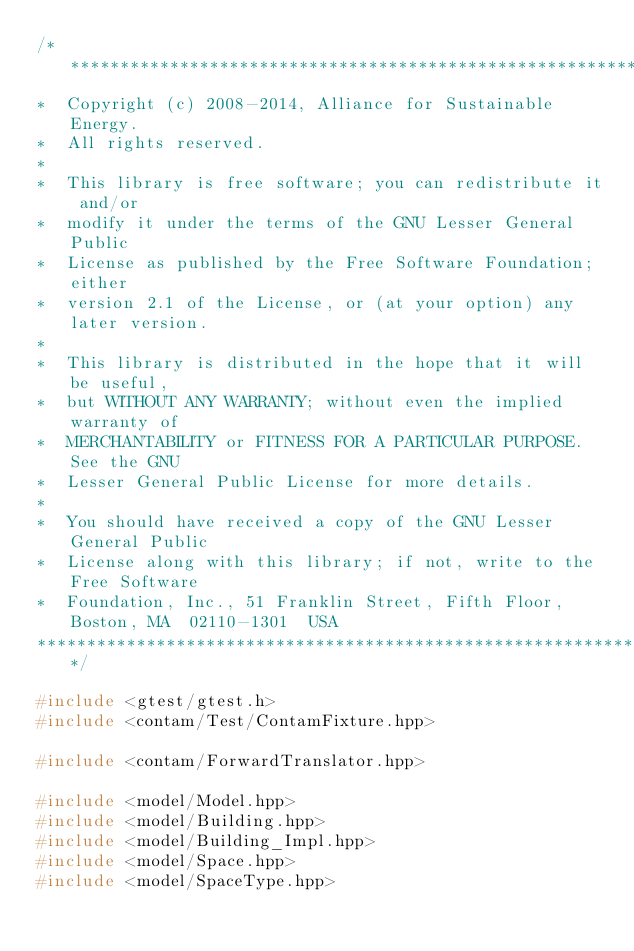<code> <loc_0><loc_0><loc_500><loc_500><_C++_>/**********************************************************************
*  Copyright (c) 2008-2014, Alliance for Sustainable Energy.
*  All rights reserved.
*
*  This library is free software; you can redistribute it and/or
*  modify it under the terms of the GNU Lesser General Public
*  License as published by the Free Software Foundation; either
*  version 2.1 of the License, or (at your option) any later version.
*
*  This library is distributed in the hope that it will be useful,
*  but WITHOUT ANY WARRANTY; without even the implied warranty of
*  MERCHANTABILITY or FITNESS FOR A PARTICULAR PURPOSE.  See the GNU
*  Lesser General Public License for more details.
*
*  You should have received a copy of the GNU Lesser General Public
*  License along with this library; if not, write to the Free Software
*  Foundation, Inc., 51 Franklin Street, Fifth Floor, Boston, MA  02110-1301  USA
**********************************************************************/

#include <gtest/gtest.h>
#include <contam/Test/ContamFixture.hpp>

#include <contam/ForwardTranslator.hpp>

#include <model/Model.hpp>
#include <model/Building.hpp>
#include <model/Building_Impl.hpp>
#include <model/Space.hpp>
#include <model/SpaceType.hpp></code> 